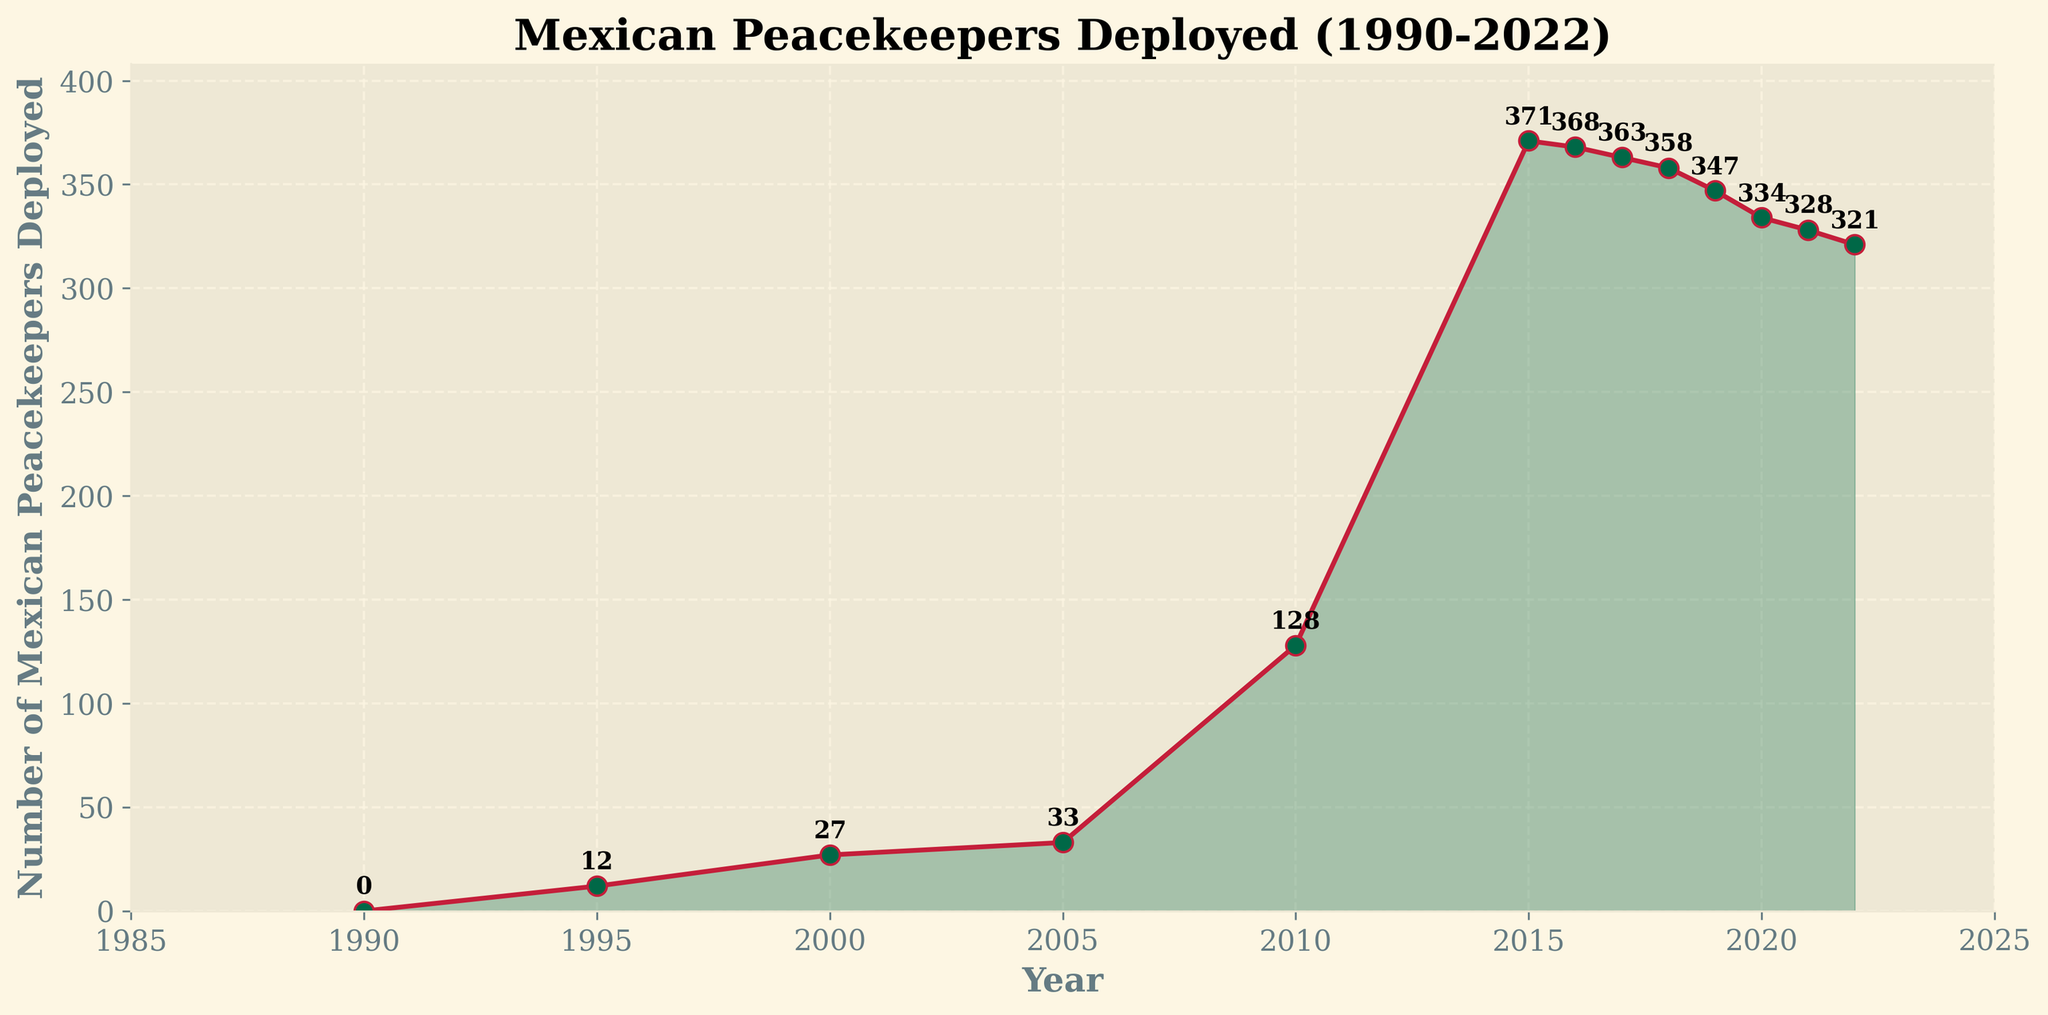What is the total number of Mexican peacekeepers deployed from 2000 to 2020? Sum the number of peacekeepers deployed for each year between 2000 and 2020: 27 (2000) + 33 (2005) + 128 (2010) + 371 (2015) + 368 (2016) + 363 (2017) + 358 (2018) + 347 (2019) + 334 (2020). The sum is 2331.
Answer: 2331 Which year saw the highest number of Mexican peacekeepers deployed? Identify the year with the highest y-value on the plot. The highest deployment is in 2015 with 371 peacekeepers.
Answer: 2015 Did the number of Mexican peacekeepers ever decrease for more than 3 consecutive years? Observe the trend lines on the plot. From 2015 to 2020, the deployment decreases each year: 371 (2015) -> 368 (2016) -> 363 (2017) -> 358 (2018) -> 347 (2019) -> 334 (2020). This is a 5-year consecutive decrease.
Answer: Yes What was the percentage increase in the number of Mexican peacekeepers from 2005 to 2010? Calculate the difference: 128 (2010) - 33 (2005) = 95. Then, divide by the 2005 value and multiply by 100: (95 / 33) * 100 ≈ 287.88%.
Answer: ≈ 287.88% How does the deployment in 2022 compare to that in 2010? Compare the values directly: 321 (2022) and 128 (2010). 2022 had more than double the number of peacekeepers deployed compared to 2010.
Answer: More than double What was the average number of peacekeepers deployed each year from 1990 to 2022? Sum the total number, then divide by the number of years: (0 + 12 + 27 + 33 + 128 + 371 + 368 + 363 + 358 + 347 + 334 + 328 + 321) / 13 ≈ 235.3.
Answer: ≈ 235.3 Which years saw a decrease in the number of Mexican peacekeepers compared to the previous year? Identify the years where each subsequent value is smaller than the previous: 2016 (371 to 368), 2017 (368 to 363), 2018 (363 to 358), 2019 (358 to 347), 2020 (347 to 334), 2021 (334 to 328), 2022 (328 to 321).
Answer: 2016, 2017, 2018, 2019, 2020, 2021, 2022 How many more peacekeepers were deployed in 2015 than in 2000? Subtract the number in 2000 from that in 2015: 371 (2015) - 27 (2000) = 344.
Answer: 344 